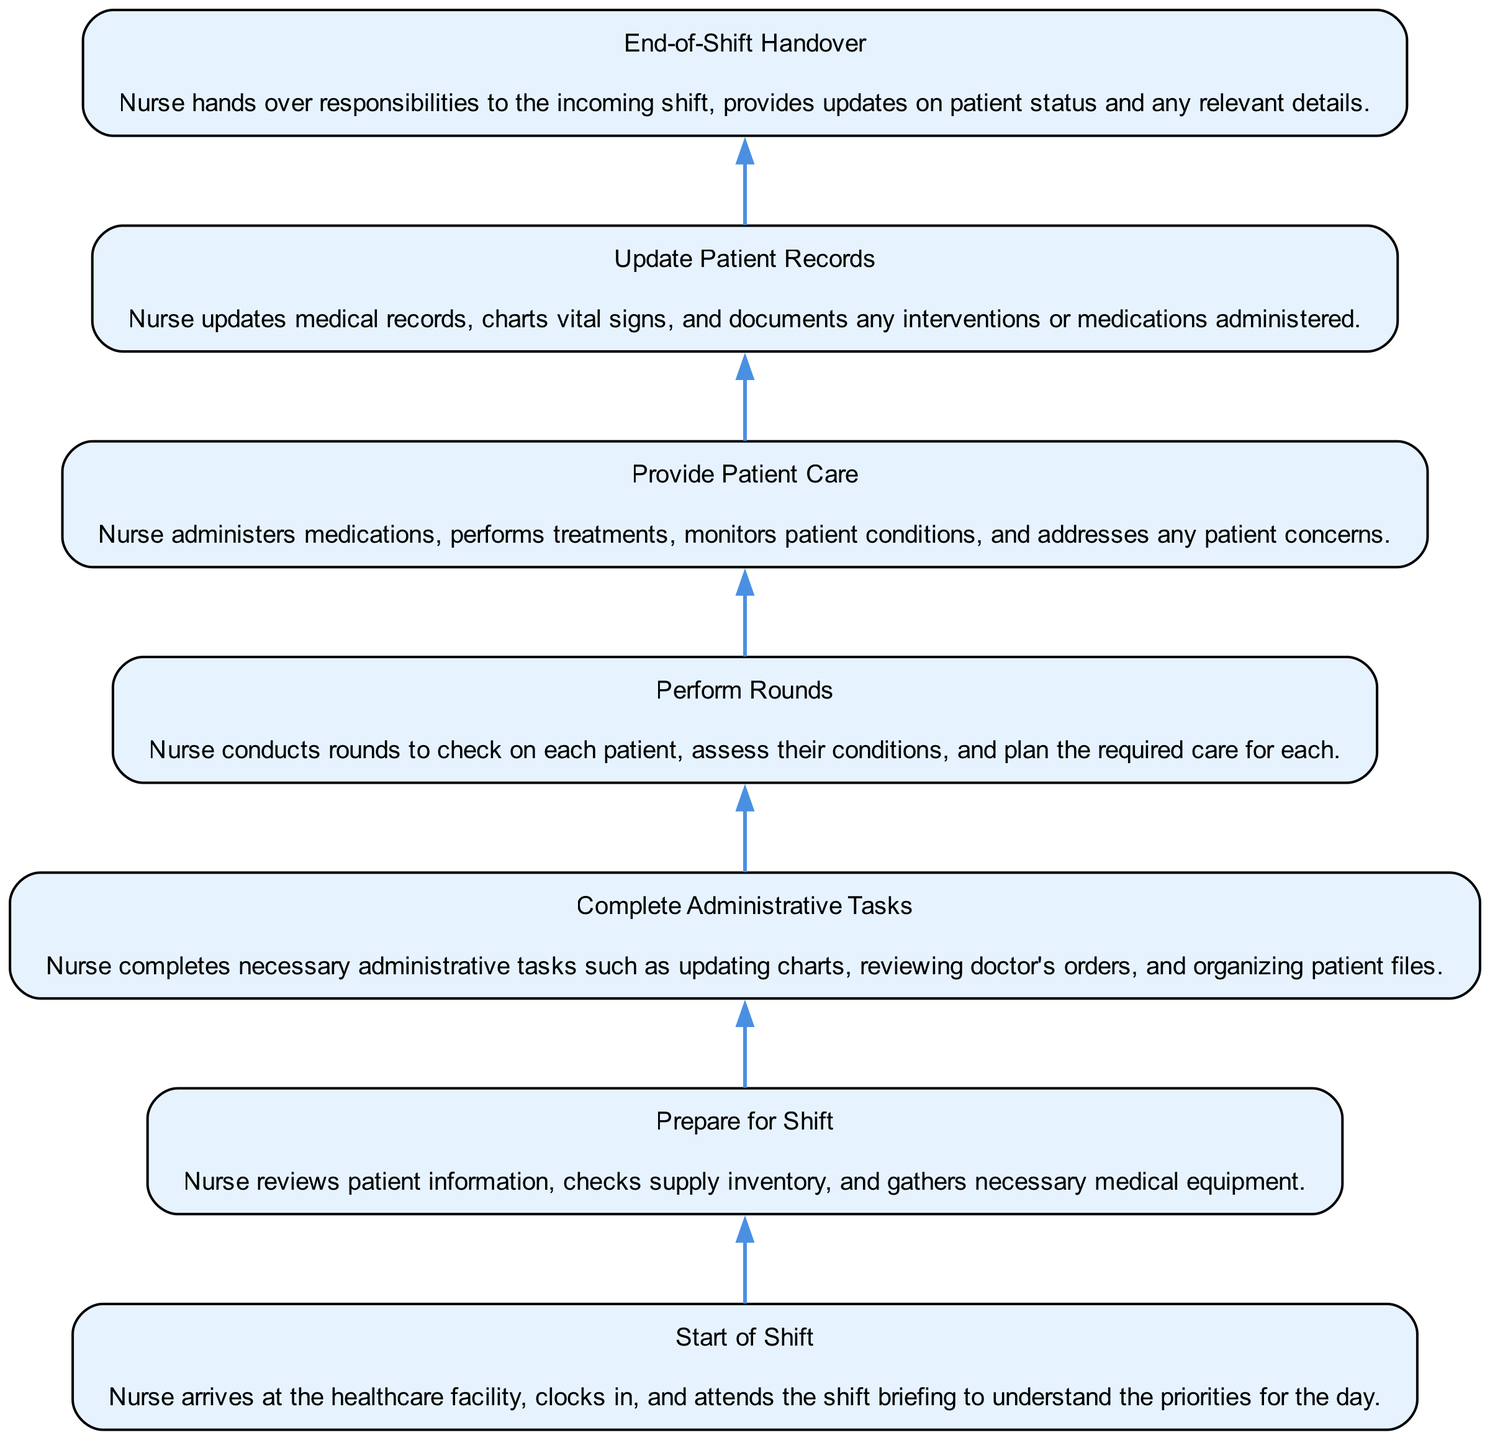What is the first step in the daily workflow of a registered nurse? The diagram indicates that the first step is "Start of Shift," where the nurse arrives, clocks in, and attends the shift briefing.
Answer: Start of Shift How many nodes are present in the workflow? By counting each unique step listed in the diagram, there are seven nodes in total, representing each significant task in the workflow.
Answer: 7 What is the last step in the workflow? The last step listed in the diagram is "End-of-Shift Handover," where the outgoing nurse hands over responsibilities to the incoming shift.
Answer: End-of-Shift Handover Which task immediately follows "Complete Administrative Tasks"? The diagram shows that the task "Prepare for Shift" immediately follows "Complete Administrative Tasks" as it is necessary before starting patient care.
Answer: Prepare for Shift If a nurse is providing patient care, which task came directly before it? The workflow indicates that "Perform Rounds" is the task that comes directly before "Provide Patient Care," as nurses conduct rounds to assess conditions before providing care.
Answer: Perform Rounds What task depends on updating patient records? According to the diagram, "Update Patient Records" depends on "Provide Patient Care," meaning patient care must be performed before records are updated.
Answer: Provide Patient Care What is the relationship between "Update Patient Records" and "End-of-Shift Handover"? The diagram shows that "End-of-Shift Handover" depends on "Update Patient Records" meaning that the nurse must update records before handing over responsibilities.
Answer: Update Patient Records How many steps are required to complete the workflow from start to end? Following the flow of the diagram, there are six sequential steps from "Start of Shift" to "End-of-Shift Handover," which illustrates the complete daily workflow.
Answer: 6 Which step involves the nurse administering medications? The diagram specifies that "Provide Patient Care" is the step where the nurse administers medications, performs treatments, and monitors patient conditions.
Answer: Provide Patient Care 